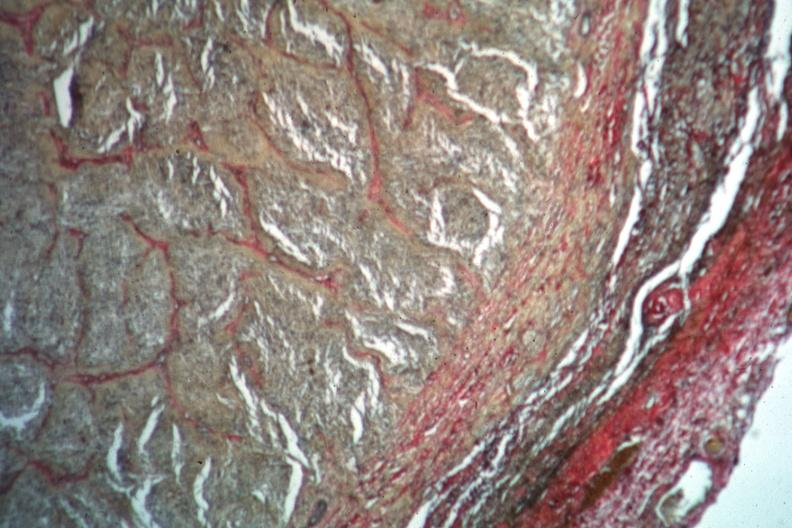s optic nerve present?
Answer the question using a single word or phrase. Yes 